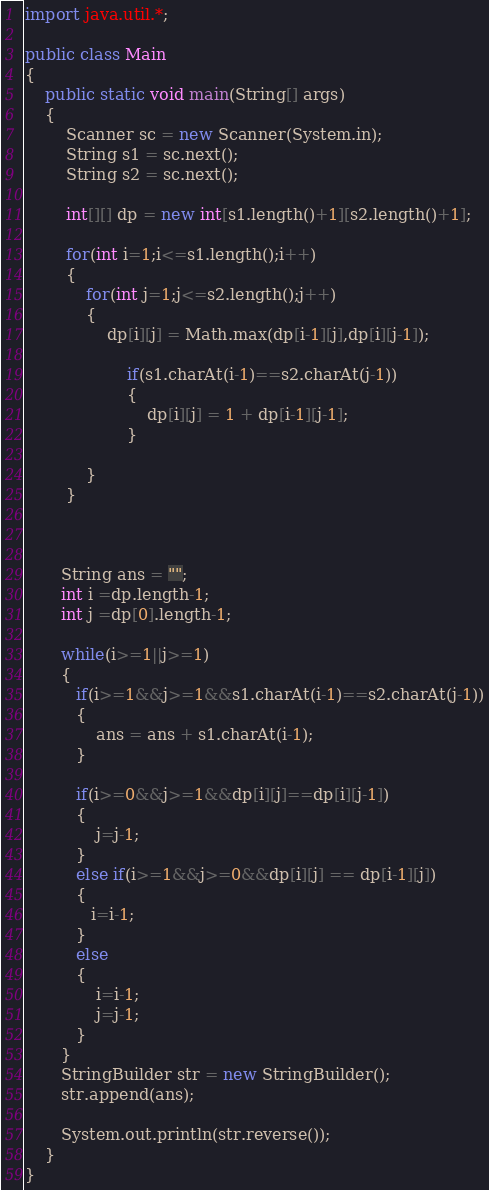<code> <loc_0><loc_0><loc_500><loc_500><_Java_>import java.util.*;

public class Main
{
	public static void main(String[] args)
	{
		Scanner sc = new Scanner(System.in);
		String s1 = sc.next();
		String s2 = sc.next();

		int[][] dp = new int[s1.length()+1][s2.length()+1];

		for(int i=1;i<=s1.length();i++)
		{
			for(int j=1;j<=s2.length();j++)
			{
				dp[i][j] = Math.max(dp[i-1][j],dp[i][j-1]);

					if(s1.charAt(i-1)==s2.charAt(j-1))
					{
						dp[i][j] = 1 + dp[i-1][j-1];
					}
					
			}
		}
       
  

       String ans = "";
       int i =dp.length-1;
       int j =dp[0].length-1;

       while(i>=1||j>=1)
       {
       	  if(i>=1&&j>=1&&s1.charAt(i-1)==s2.charAt(j-1))
       	  {
       	  	  ans = ans + s1.charAt(i-1);
       	  }

       	  if(i>=0&&j>=1&&dp[i][j]==dp[i][j-1])
       	  {
              j=j-1;
       	  }
       	  else if(i>=1&&j>=0&&dp[i][j] == dp[i-1][j])
       	  {
             i=i-1;
       	  }
       	  else
       	  {
              i=i-1;
              j=j-1;
       	  }
       }
       StringBuilder str = new StringBuilder();
       str.append(ans);

       System.out.println(str.reverse());
 	}
}</code> 